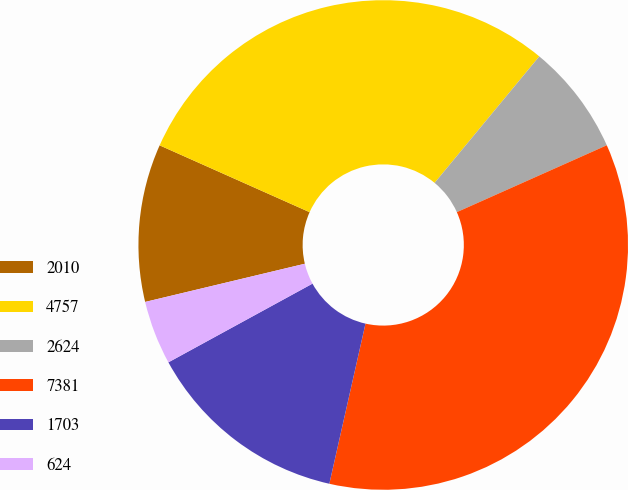Convert chart to OTSL. <chart><loc_0><loc_0><loc_500><loc_500><pie_chart><fcel>2010<fcel>4757<fcel>2624<fcel>7381<fcel>1703<fcel>624<nl><fcel>10.41%<fcel>29.33%<fcel>7.32%<fcel>35.21%<fcel>13.51%<fcel>4.22%<nl></chart> 